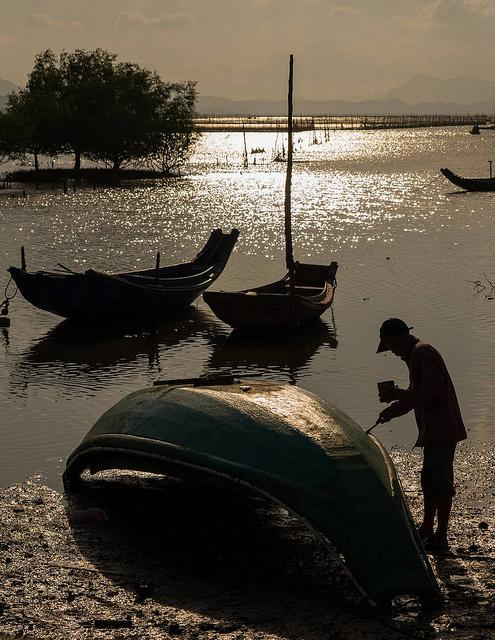What is the goal of the man working on the boat here? Please explain your reasoning. waterproofing. He is fixing the boat so there won't be any leaks 